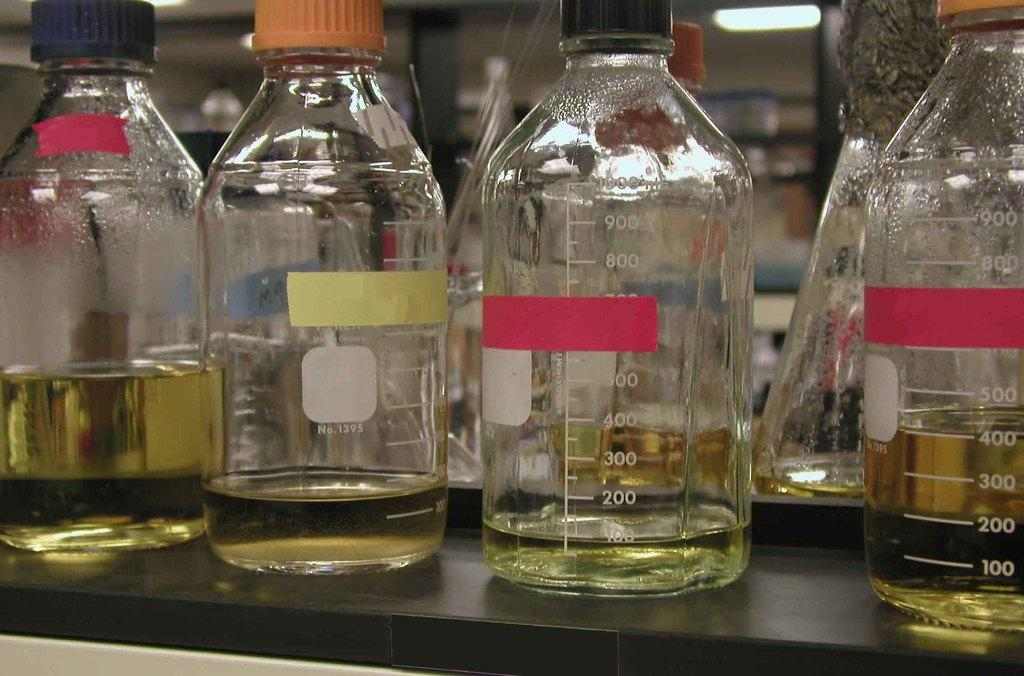<image>
Describe the image concisely. Jars able to measure up to 1000ml are on a table with different amounts of liquid in them. 